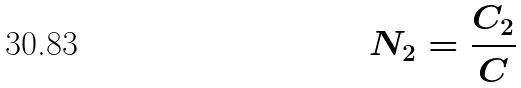<formula> <loc_0><loc_0><loc_500><loc_500>N _ { 2 } = \frac { C _ { 2 } } { C }</formula> 